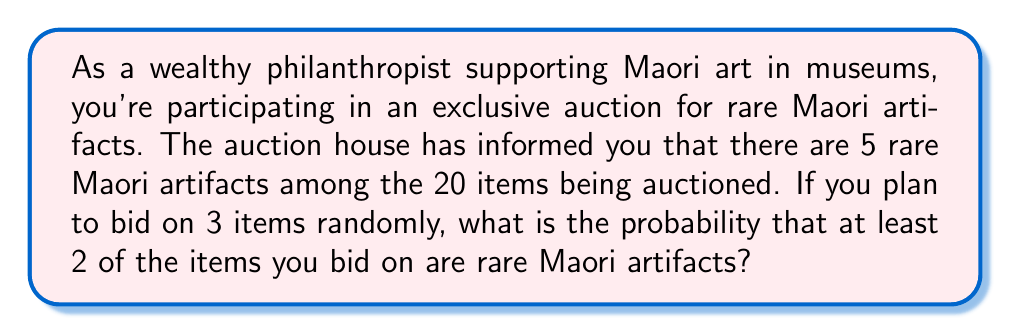Can you solve this math problem? To solve this problem, we'll use the concept of hypergeometric distribution and the complement rule of probability.

1) First, let's define our parameters:
   - Total items: $N = 20$
   - Rare Maori artifacts: $K = 5$
   - Items you're bidding on: $n = 3$

2) We need to find P(at least 2 rare artifacts). This is equal to:
   P(2 rare artifacts) + P(3 rare artifacts)

3) It's easier to calculate P(at least 2 rare artifacts) using the complement rule:
   P(at least 2 rare artifacts) = 1 - P(0 or 1 rare artifact)

4) Now we can use the hypergeometric distribution formula:

   $$P(X = k) = \frac{\binom{K}{k} \binom{N-K}{n-k}}{\binom{N}{n}}$$

   Where $k$ is the number of rare artifacts we're calculating for.

5) Calculate P(0 rare artifacts):

   $$P(X = 0) = \frac{\binom{5}{0} \binom{15}{3}}{\binom{20}{3}} = \frac{1 \cdot 455}{1140} = \frac{455}{1140}$$

6) Calculate P(1 rare artifact):

   $$P(X = 1) = \frac{\binom{5}{1} \binom{15}{2}}{\binom{20}{3}} = \frac{5 \cdot 105}{1140} = \frac{525}{1140}$$

7) Sum these probabilities:
   P(0 or 1 rare artifact) = $\frac{455}{1140} + \frac{525}{1140} = \frac{980}{1140}$

8) Apply the complement rule:
   P(at least 2 rare artifacts) = $1 - \frac{980}{1140} = \frac{160}{1140} \approx 0.1404$
Answer: The probability of bidding on at least 2 rare Maori artifacts out of 3 random bids is $\frac{160}{1140}$ or approximately 0.1404 (14.04%). 